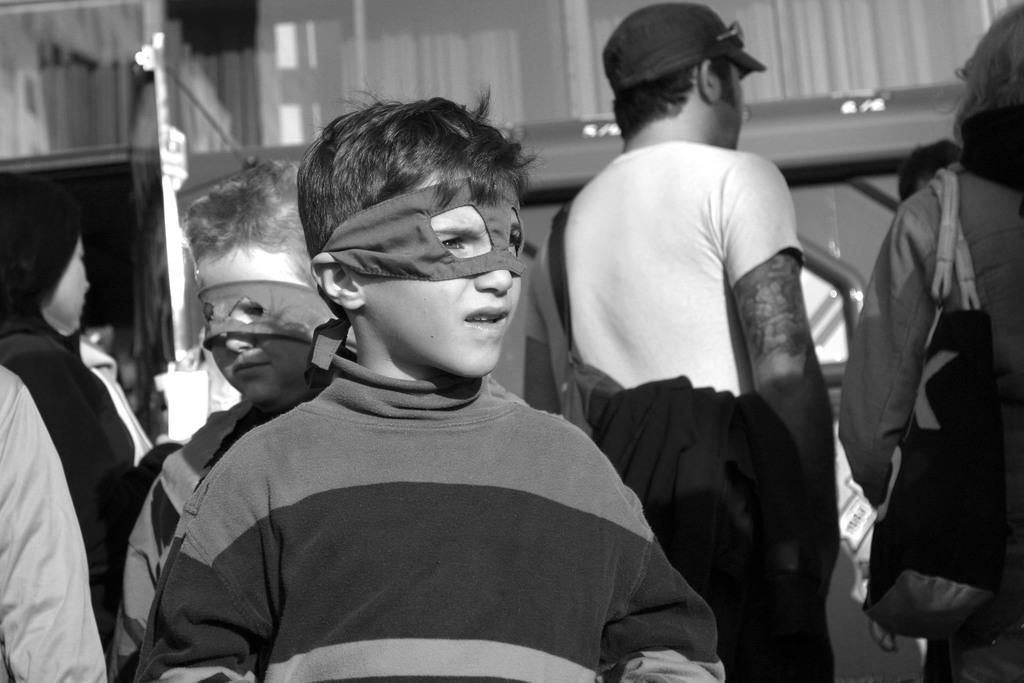How many children are present in the image? There are two children in the image. What are the children wearing on their faces? The children are wearing masks on their faces. Can you describe the people standing behind the children? There are people standing behind the children, but their specific features cannot be determined due to the black and white nature of the image. What type of sponge is being used by the mother in the image? There is no mother or sponge present in the image. Can you describe the insect that is crawling on the child's shoulder in the image? There is no insect present in the image; the children are wearing masks on their faces. 